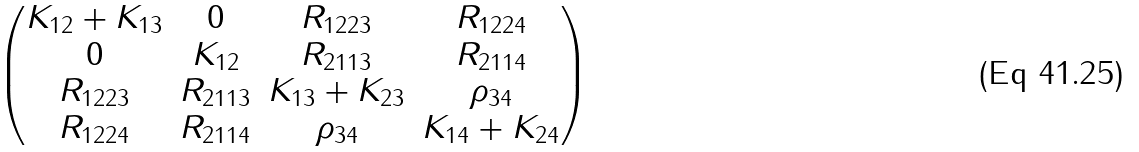<formula> <loc_0><loc_0><loc_500><loc_500>\begin{pmatrix} K _ { 1 2 } + K _ { 1 3 } & 0 & R _ { 1 2 2 3 } & R _ { 1 2 2 4 } \\ 0 & K _ { 1 2 } & R _ { 2 1 1 3 } & R _ { 2 1 1 4 } \\ R _ { 1 2 2 3 } & R _ { 2 1 1 3 } & K _ { 1 3 } + K _ { 2 3 } & \rho _ { 3 4 } \\ R _ { 1 2 2 4 } & R _ { 2 1 1 4 } & \rho _ { 3 4 } & K _ { 1 4 } + K _ { 2 4 } \end{pmatrix}</formula> 